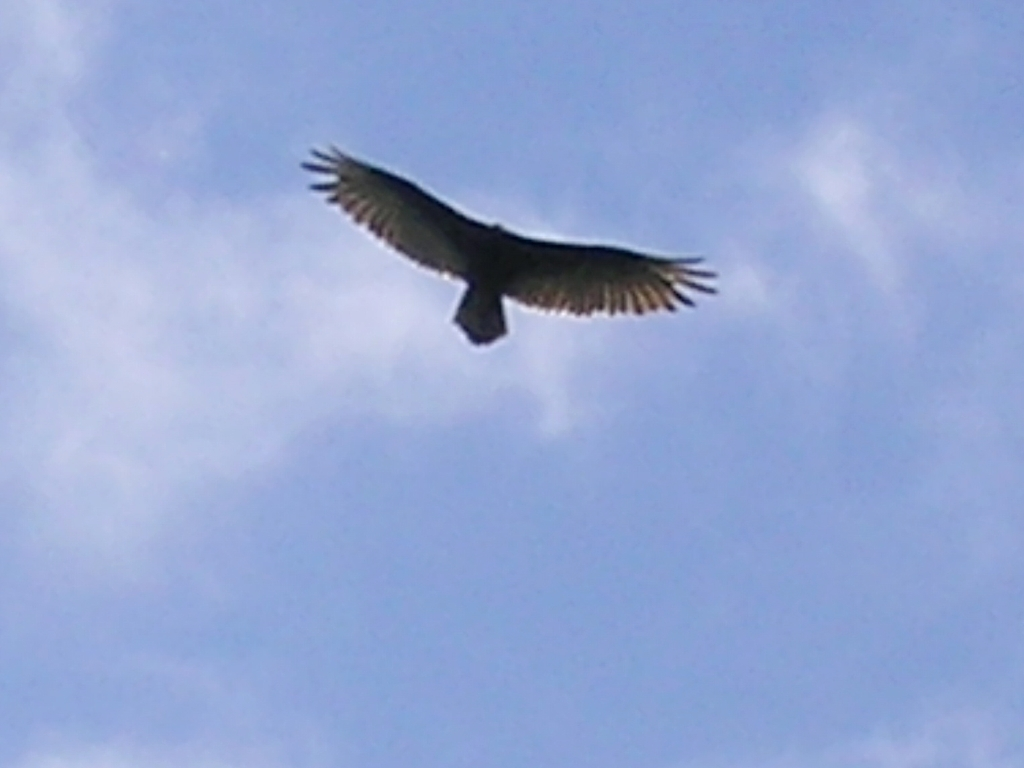Can you describe what is happening in the image? The image captures a bird in mid-flight under a blue sky. The bird is at a considerable distance and is shown from below, evident by the view of its wings spread wide, likely utilizing updrafts for flight. The details of the bird are not clear, but its silhouette against the sky suggests it may be a large bird of prey. 